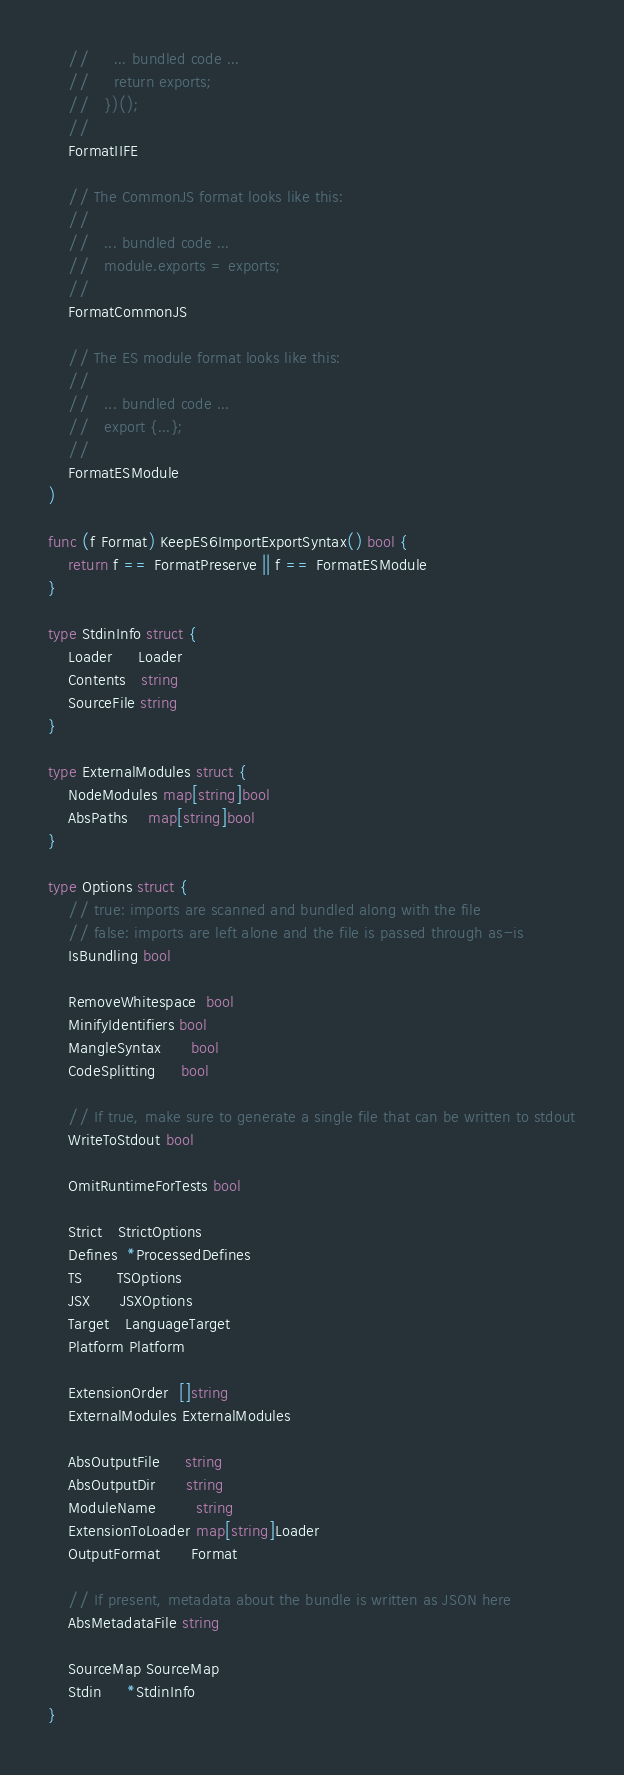Convert code to text. <code><loc_0><loc_0><loc_500><loc_500><_Go_>	//     ... bundled code ...
	//     return exports;
	//   })();
	//
	FormatIIFE

	// The CommonJS format looks like this:
	//
	//   ... bundled code ...
	//   module.exports = exports;
	//
	FormatCommonJS

	// The ES module format looks like this:
	//
	//   ... bundled code ...
	//   export {...};
	//
	FormatESModule
)

func (f Format) KeepES6ImportExportSyntax() bool {
	return f == FormatPreserve || f == FormatESModule
}

type StdinInfo struct {
	Loader     Loader
	Contents   string
	SourceFile string
}

type ExternalModules struct {
	NodeModules map[string]bool
	AbsPaths    map[string]bool
}

type Options struct {
	// true: imports are scanned and bundled along with the file
	// false: imports are left alone and the file is passed through as-is
	IsBundling bool

	RemoveWhitespace  bool
	MinifyIdentifiers bool
	MangleSyntax      bool
	CodeSplitting     bool

	// If true, make sure to generate a single file that can be written to stdout
	WriteToStdout bool

	OmitRuntimeForTests bool

	Strict   StrictOptions
	Defines  *ProcessedDefines
	TS       TSOptions
	JSX      JSXOptions
	Target   LanguageTarget
	Platform Platform

	ExtensionOrder  []string
	ExternalModules ExternalModules

	AbsOutputFile     string
	AbsOutputDir      string
	ModuleName        string
	ExtensionToLoader map[string]Loader
	OutputFormat      Format

	// If present, metadata about the bundle is written as JSON here
	AbsMetadataFile string

	SourceMap SourceMap
	Stdin     *StdinInfo
}
</code> 